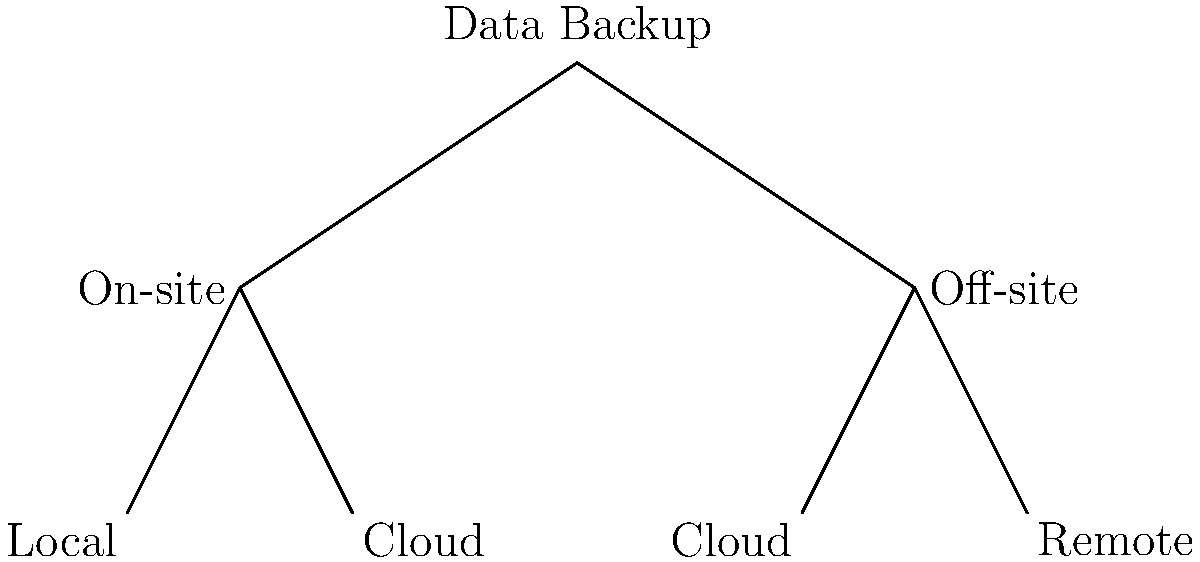As a software engineer specializing in database management systems, which combination of backup strategies would provide the most comprehensive protection against data loss according to the tree diagram? To determine the most comprehensive protection against data loss, let's analyze the backup strategies shown in the tree diagram:

1. The diagram shows two main branches: On-site and Off-site backups.

2. On-site backups are further divided into:
   a) Local: Stored within the same physical location as the primary data.
   b) Cloud: Stored in a cloud service but managed on-site.

3. Off-site backups are also divided into:
   a) Cloud: Stored and managed by a third-party cloud service provider.
   b) Remote: Stored in a separate physical location managed by the organization.

4. A comprehensive backup strategy should include both on-site and off-site backups to protect against different types of data loss scenarios:
   - On-site backups provide quick access for immediate recovery.
   - Off-site backups protect against localized disasters that might affect the primary site.

5. Within each category, it's beneficial to have multiple options:
   - Local backups for fastest recovery of small-scale losses.
   - Cloud backups for scalability and accessibility.
   - Remote backups for an additional layer of protection against widespread disasters.

6. The most comprehensive approach would be to implement all four strategies: Local, Cloud (on-site), Cloud (off-site), and Remote.

This combination provides:
- Immediate access to data (Local)
- Scalability and ease of management (Cloud - both on-site and off-site)
- Protection against localized and widespread disasters (Remote)
Answer: Local + On-site Cloud + Off-site Cloud + Remote 